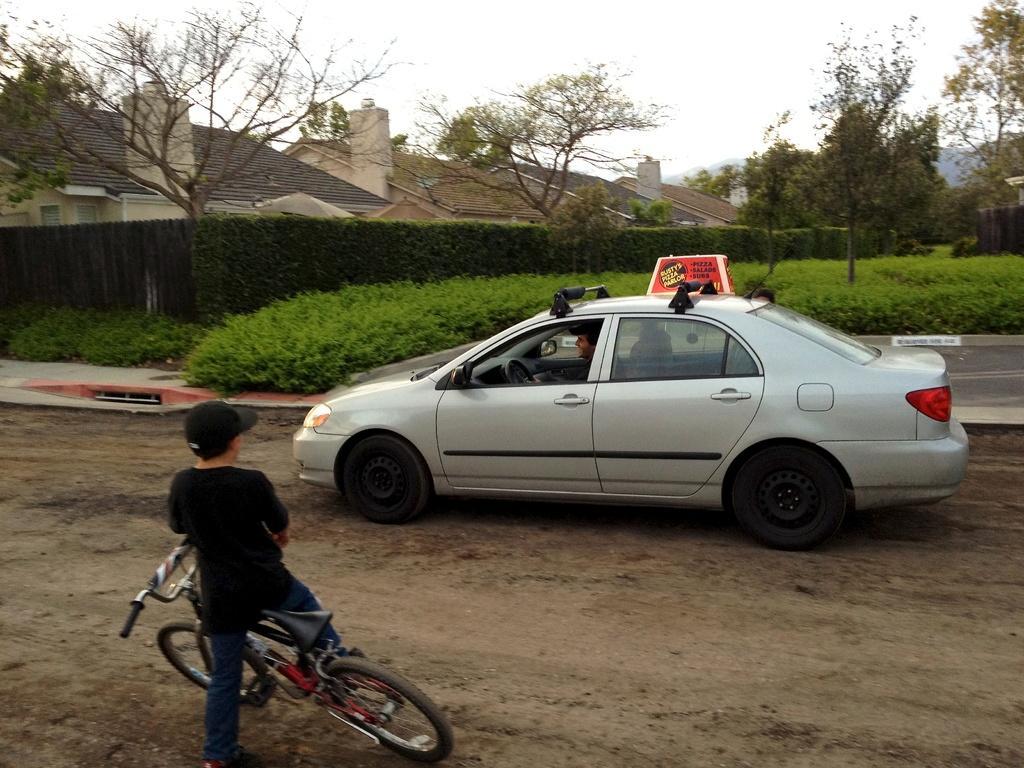Can you describe this image briefly? In this image i can see a boy wearing a hat a t shirt and blue jeans on the bicycle. I can see a silver car in which a person is sitting. In the background i can see few plants, few trees, few buildings , mountains and the sky. 